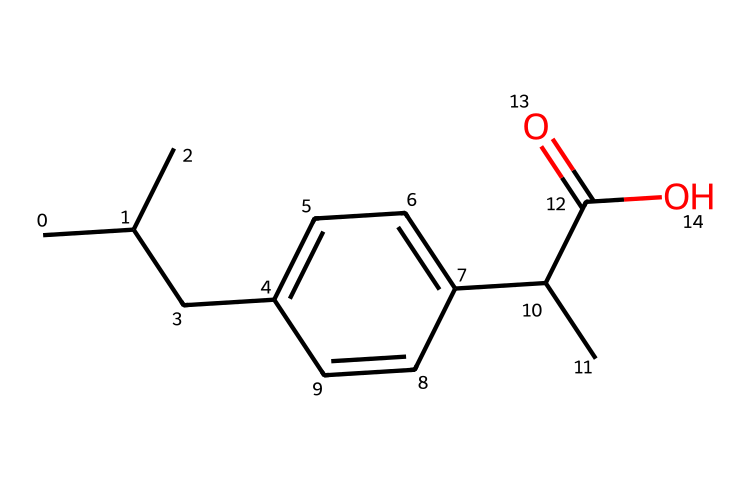What is the common name of this chemical? The SMILES representation corresponds to ibuprofen, which is commonly known as a nonsteroidal anti-inflammatory drug (NSAID) used for pain relief.
Answer: ibuprofen How many carbon atoms are present in this chemical? The structure reveals that there are 13 carbon atoms indicated in the SMILES string, counted from the 'C' symbols.
Answer: 13 What type of bonding is primarily present in this molecule? The molecule exhibits primarily covalent bonding, as it is composed of nonmetal atoms forming stable interactions.
Answer: covalent Which functional group is represented by "C(=O)O"? The "C(=O)O" portion of the SMILES indicates a carboxylic acid functional group, characterized by the presence of a carbonyl group (C=O) bonded to a hydroxyl group (–OH).
Answer: carboxylic acid What is the primary role of ibuprofen in sports? Ibuprofen is primarily used for pain management, especially to alleviate muscle soreness and inflammation commonly experienced by athletes.
Answer: pain management How does the presence of the aromatic ring affect the properties of ibuprofen? The aromatic ring contributes to the lipophilicity and stabilizes the molecule, enhancing its interaction with biological membranes and improving drug properties like absorption.
Answer: enhances lipophilicity What effect does ibuprofen have on inflammation in athletic injuries? Ibuprofen inhibits cyclooxygenase (COX) enzymes, reducing the production of prostaglandins, which are responsible for pain and inflammation in athletic injuries.
Answer: reduces inflammation 